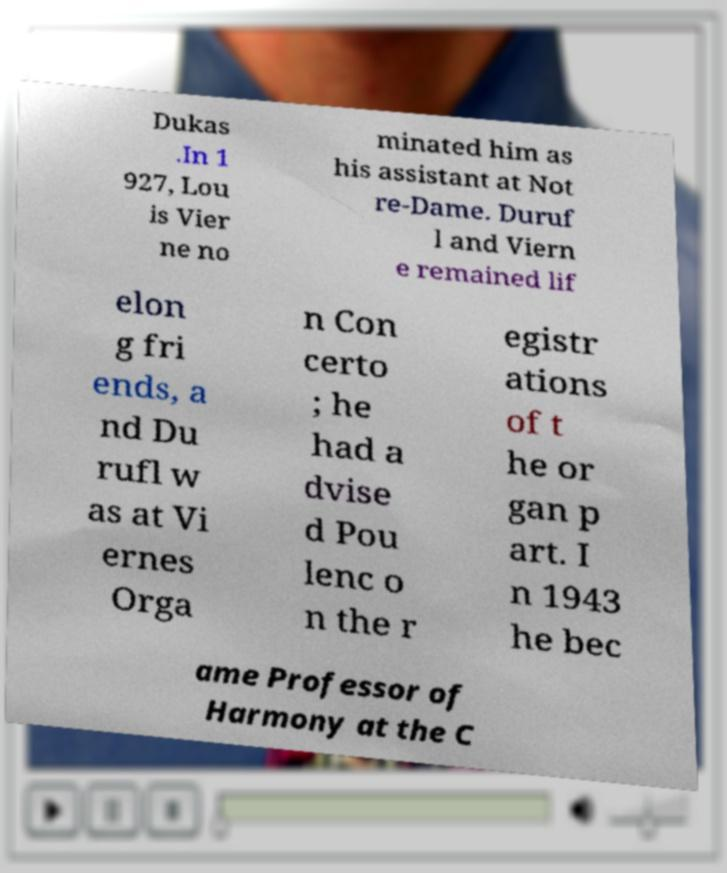Can you accurately transcribe the text from the provided image for me? Dukas .In 1 927, Lou is Vier ne no minated him as his assistant at Not re-Dame. Duruf l and Viern e remained lif elon g fri ends, a nd Du rufl w as at Vi ernes Orga n Con certo ; he had a dvise d Pou lenc o n the r egistr ations of t he or gan p art. I n 1943 he bec ame Professor of Harmony at the C 